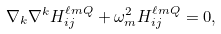<formula> <loc_0><loc_0><loc_500><loc_500>\nabla _ { k } \nabla ^ { k } H ^ { \ell m Q } _ { i j } + \omega ^ { 2 } _ { m } H ^ { \ell m Q } _ { i j } = 0 ,</formula> 